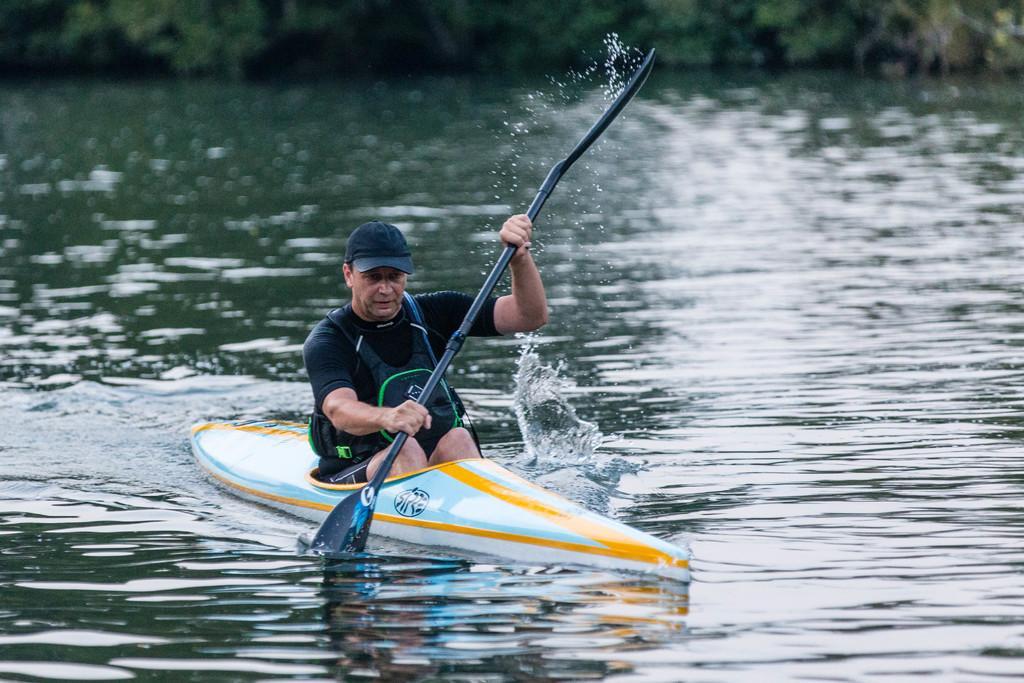Please provide a concise description of this image. In the picture we can see a person wearing black color T-shirt, life jacket sitting in a boat and holding oar in his hands and rowing, in the background of the picture there are some trees and there is water. 